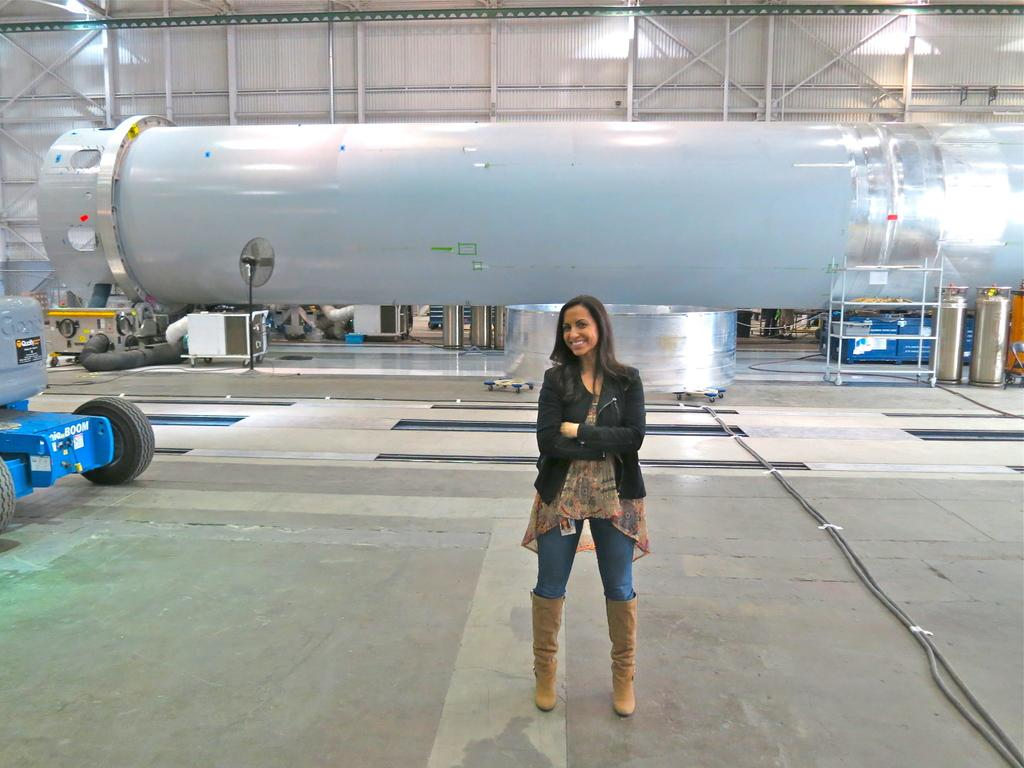What is the primary subject in the image? There is a woman standing in the image. What is the woman standing on? The woman is standing on the ground. What can be seen in the background of the image? There is a vehicle, a fan, a rack, and some objects in the background of the image. How many legs does the oven have in the image? There is no oven present in the image. What advice does the woman's father give her in the image? There is no father or any conversation depicted in the image. 